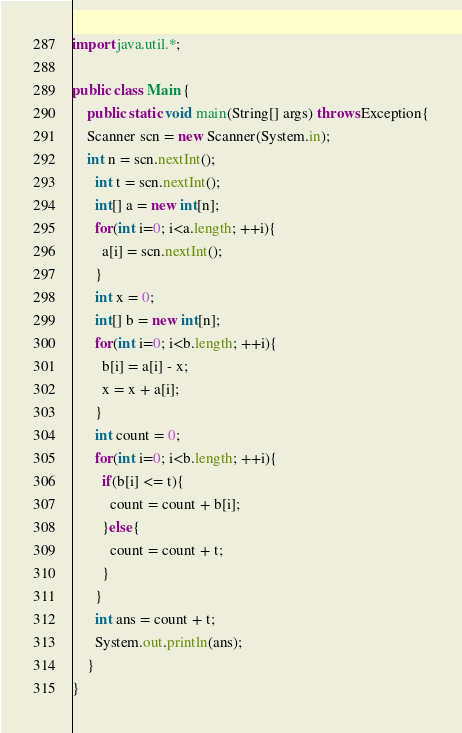<code> <loc_0><loc_0><loc_500><loc_500><_Java_>import java.util.*;

public class Main {
	public static void main(String[] args) throws Exception{
	Scanner scn = new Scanner(System.in);
	int n = scn.nextInt();
      int t = scn.nextInt();
      int[] a = new int[n];
      for(int i=0; i<a.length; ++i){
        a[i] = scn.nextInt();
      }
      int x = 0;
      int[] b = new int[n];
      for(int i=0; i<b.length; ++i){
        b[i] = a[i] - x;
        x = x + a[i];
      }
      int count = 0;
      for(int i=0; i<b.length; ++i){
        if(b[i] <= t){
          count = count + b[i];
        }else{
          count = count + t;
        }
      }
      int ans = count + t;
      System.out.println(ans);
	}
}</code> 